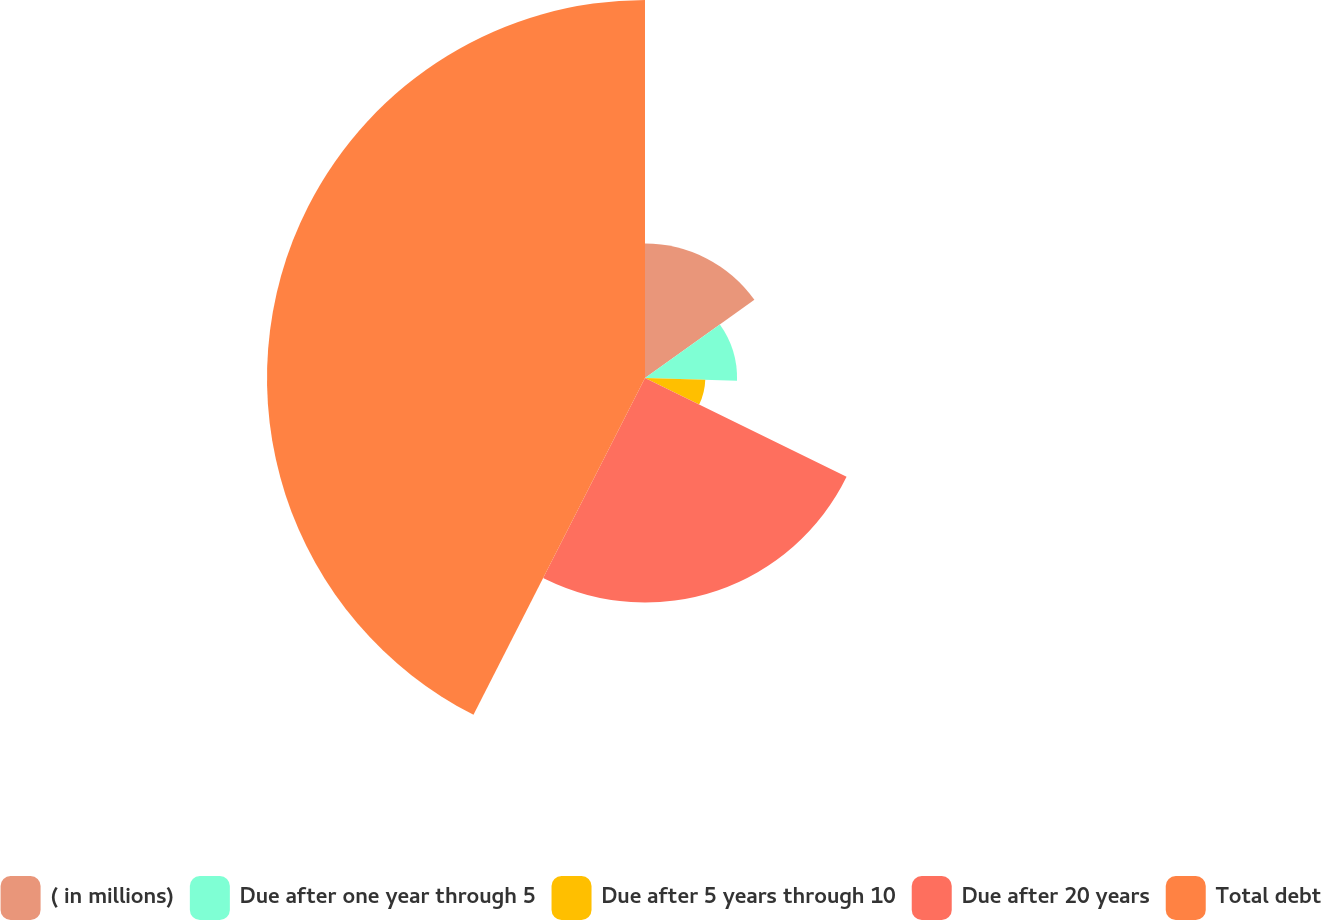Convert chart to OTSL. <chart><loc_0><loc_0><loc_500><loc_500><pie_chart><fcel>( in millions)<fcel>Due after one year through 5<fcel>Due after 5 years through 10<fcel>Due after 20 years<fcel>Total debt<nl><fcel>15.12%<fcel>10.35%<fcel>6.78%<fcel>25.24%<fcel>42.5%<nl></chart> 